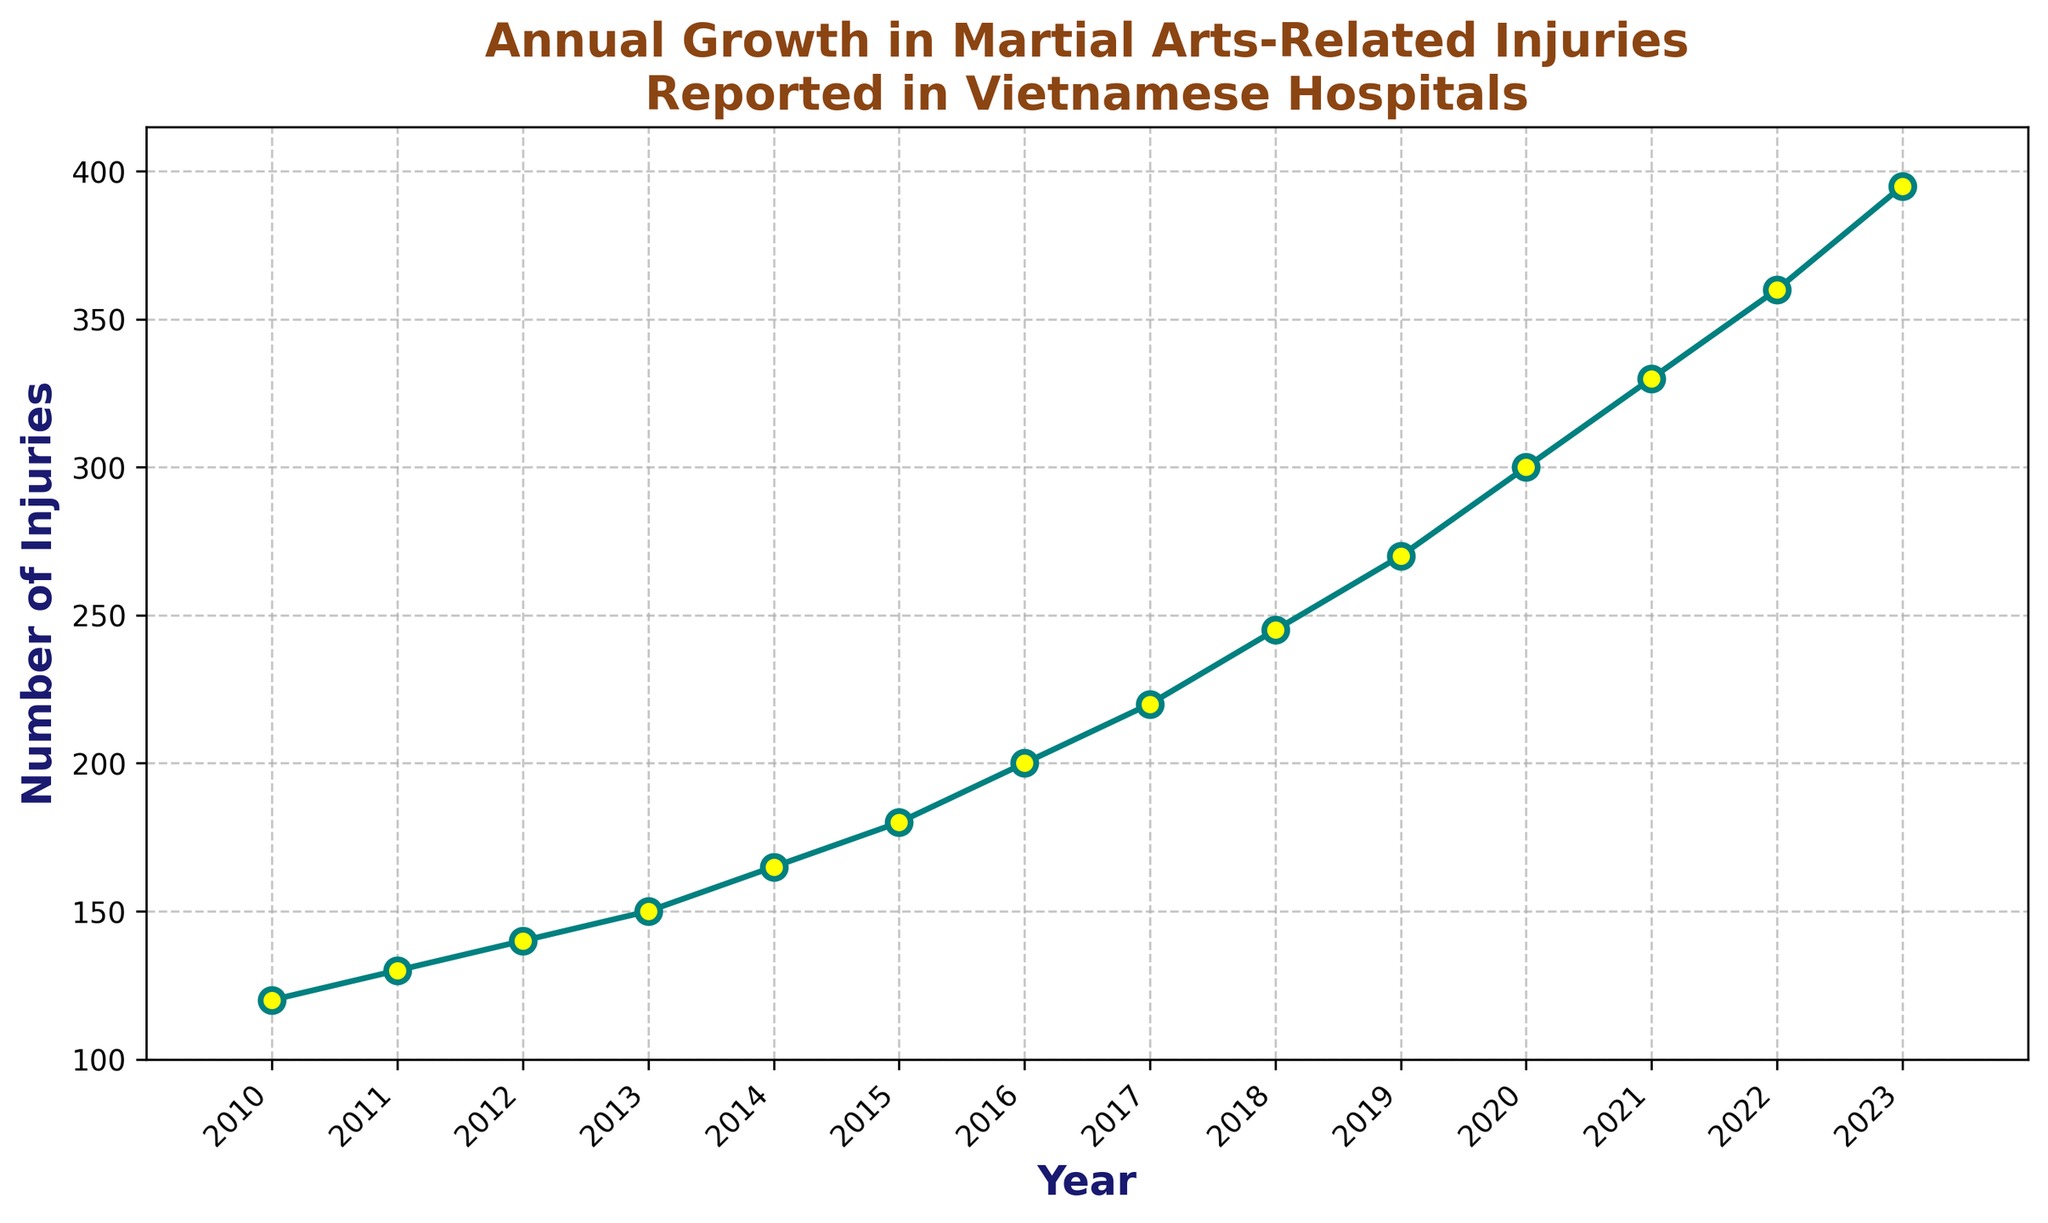What is the total number of injuries reported from 2010 to 2023? To get the total number of injuries, sum the values from each year between 2010 and 2023: 120 + 130 + 140 + 150 + 165 + 180 + 200 + 220 + 245 + 270 + 300 + 330 + 360 + 395 = 3205
Answer: 3205 Which year had the highest number of injuries reported? Look at the plot and identify the year with the highest y-value. The corresponding year is 2023 with 395 injuries.
Answer: 2023 What is the difference in the number of injuries between the years 2015 and 2020? From the graph, the number of injuries in 2015 is 180 and in 2020 is 300. Subtract 180 from 300 to find the difference: 300 - 180 = 120
Answer: 120 How many years did the number of injuries increase by more than 20 from the previous year? Check the differences year-over-year and count instances where the increase is more than 20: 2013-2014 (15), 2014-2015 (15), 2015-2016 (20), 2016-2017 (20), 2017-2018 (25), 2018-2019 (25), 2019-2020 (30), 2020-2021 (30), 2021-2022 (30), 2022-2023 (35). There are 6 such years (2017-2018, 2018-2019, 2019-2020, 2020-2021, 2021-2022, and 2022-2023).
Answer: 6 What is the average annual growth in the number of injuries from 2010 to 2023? To find the average annual growth: (Number of injuries in 2023 - Number of injuries in 2010) / (2023 - 2010): (395 - 120) / (2023 - 2010) = 275 / 13 ≈ 21.15
Answer: 21.15 By how many injuries did the number of reported injuries increase from 2011 to 2023? Subtract the number of injuries in 2011 from the number of injuries in 2023: 395 - 130 = 265
Answer: 265 In which year did the injuries reported surpass 200 for the first time? Locate the point on the graph where the y-value first exceeds 200. This happens in the year 2016.
Answer: 2016 Between which years did the number of injuries increase the most? Calculate the year-over-year differences and find the largest increase. The largest increase is from 2022 to 2023 (395 - 360 = 35).
Answer: 2022-2023 What visual elements indicate the trend in injuries over the years? The line chart uses a teal-colored line with yellow markers, and the line consistently slopes upwards from 2010 to 2023, indicating an increasing trend in injuries.
Answer: Upward-sloping line, teal color with yellow markers 